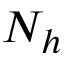<formula> <loc_0><loc_0><loc_500><loc_500>N _ { h }</formula> 